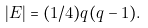Convert formula to latex. <formula><loc_0><loc_0><loc_500><loc_500>| E | = ( 1 / 4 ) q ( q - 1 ) .</formula> 